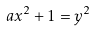<formula> <loc_0><loc_0><loc_500><loc_500>a x ^ { 2 } + 1 = y ^ { 2 }</formula> 